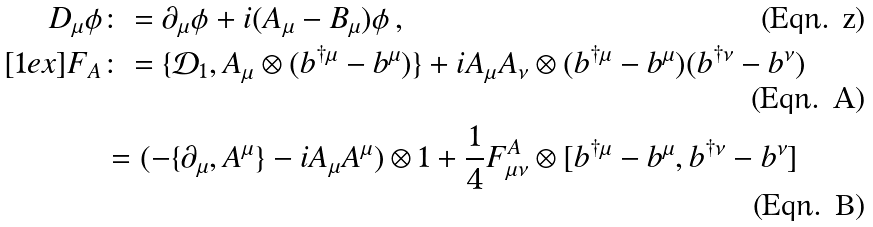Convert formula to latex. <formula><loc_0><loc_0><loc_500><loc_500>D _ { \mu } \phi & \colon = \partial _ { \mu } \phi + i ( A _ { \mu } - B _ { \mu } ) \phi \, , \\ [ 1 e x ] F _ { A } & \colon = \{ \mathcal { D } _ { 1 } , A _ { \mu } \otimes ( b ^ { \dag \mu } - b ^ { \mu } ) \} + i A _ { \mu } A _ { \nu } \otimes ( b ^ { \dag \mu } - b ^ { \mu } ) ( b ^ { \dag \nu } - b ^ { \nu } ) \\ & = ( - \{ \partial _ { \mu } , A ^ { \mu } \} - i A _ { \mu } A ^ { \mu } ) \otimes 1 + \frac { 1 } { 4 } F ^ { A } _ { \mu \nu } \otimes [ b ^ { \dag \mu } - b ^ { \mu } , b ^ { \dag \nu } - b ^ { \nu } ]</formula> 